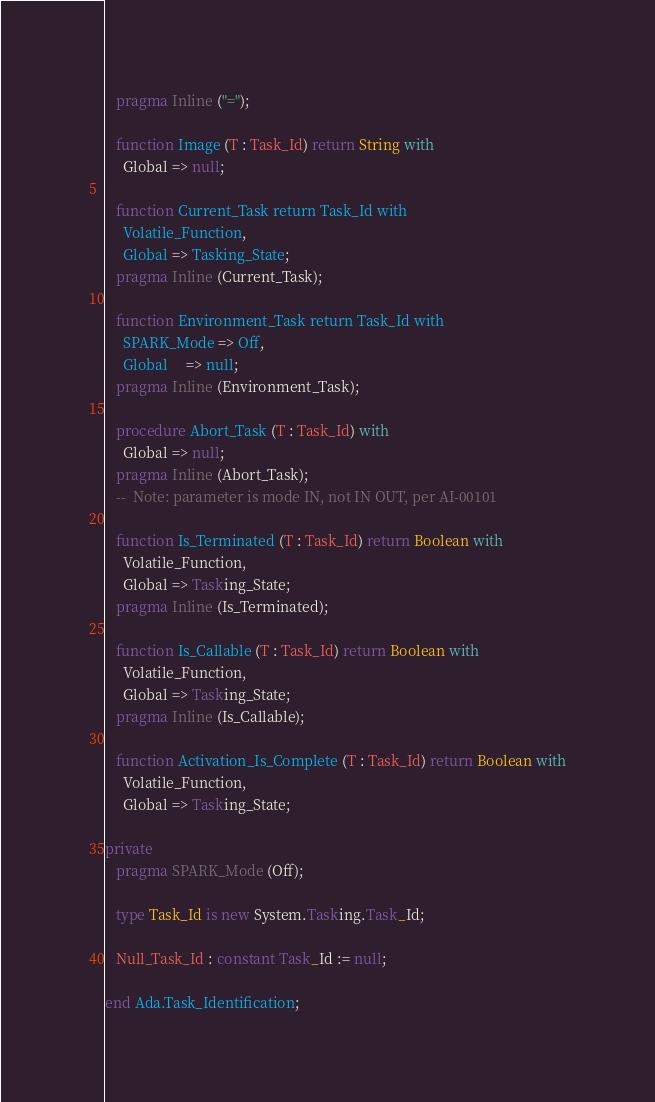<code> <loc_0><loc_0><loc_500><loc_500><_Ada_>   pragma Inline ("=");

   function Image (T : Task_Id) return String with
     Global => null;

   function Current_Task return Task_Id with
     Volatile_Function,
     Global => Tasking_State;
   pragma Inline (Current_Task);

   function Environment_Task return Task_Id with
     SPARK_Mode => Off,
     Global     => null;
   pragma Inline (Environment_Task);

   procedure Abort_Task (T : Task_Id) with
     Global => null;
   pragma Inline (Abort_Task);
   --  Note: parameter is mode IN, not IN OUT, per AI-00101

   function Is_Terminated (T : Task_Id) return Boolean with
     Volatile_Function,
     Global => Tasking_State;
   pragma Inline (Is_Terminated);

   function Is_Callable (T : Task_Id) return Boolean with
     Volatile_Function,
     Global => Tasking_State;
   pragma Inline (Is_Callable);

   function Activation_Is_Complete (T : Task_Id) return Boolean with
     Volatile_Function,
     Global => Tasking_State;

private
   pragma SPARK_Mode (Off);

   type Task_Id is new System.Tasking.Task_Id;

   Null_Task_Id : constant Task_Id := null;

end Ada.Task_Identification;
</code> 